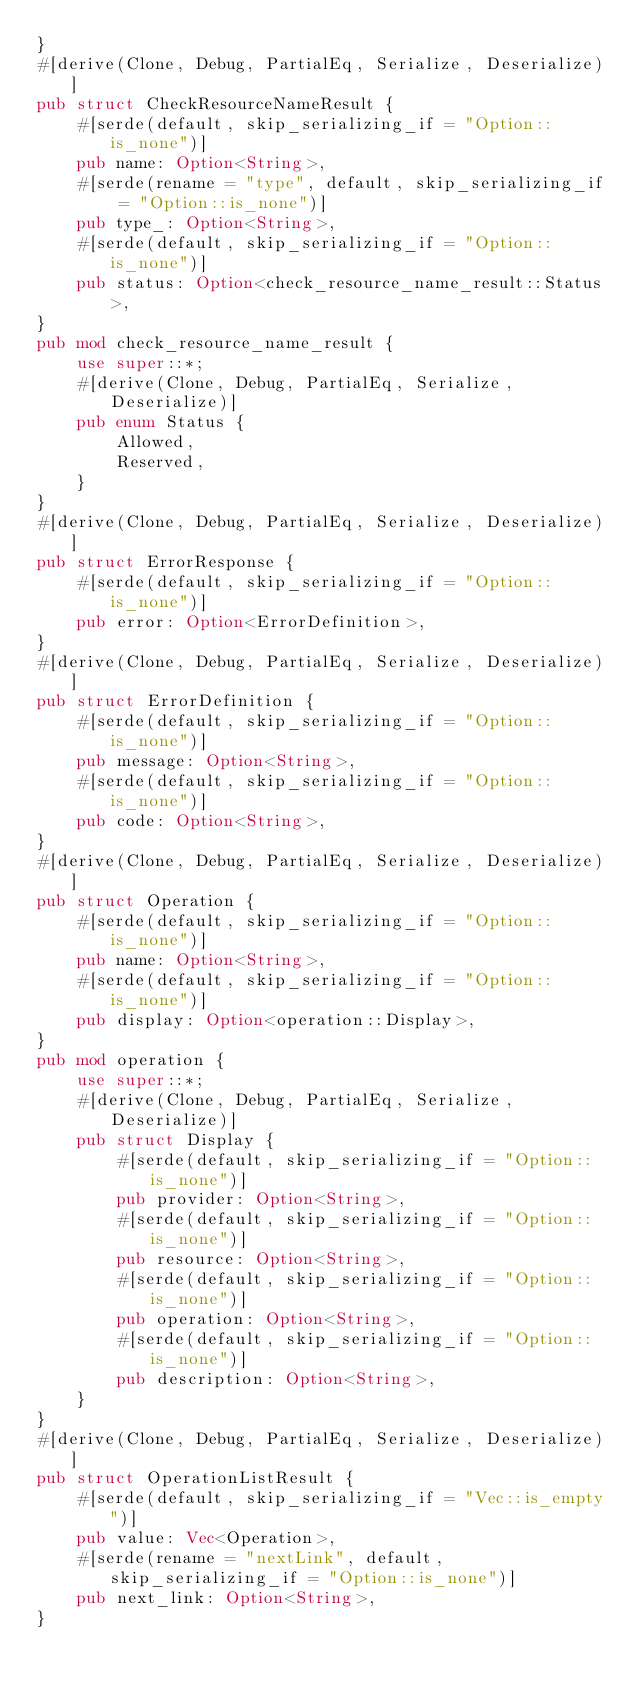Convert code to text. <code><loc_0><loc_0><loc_500><loc_500><_Rust_>}
#[derive(Clone, Debug, PartialEq, Serialize, Deserialize)]
pub struct CheckResourceNameResult {
    #[serde(default, skip_serializing_if = "Option::is_none")]
    pub name: Option<String>,
    #[serde(rename = "type", default, skip_serializing_if = "Option::is_none")]
    pub type_: Option<String>,
    #[serde(default, skip_serializing_if = "Option::is_none")]
    pub status: Option<check_resource_name_result::Status>,
}
pub mod check_resource_name_result {
    use super::*;
    #[derive(Clone, Debug, PartialEq, Serialize, Deserialize)]
    pub enum Status {
        Allowed,
        Reserved,
    }
}
#[derive(Clone, Debug, PartialEq, Serialize, Deserialize)]
pub struct ErrorResponse {
    #[serde(default, skip_serializing_if = "Option::is_none")]
    pub error: Option<ErrorDefinition>,
}
#[derive(Clone, Debug, PartialEq, Serialize, Deserialize)]
pub struct ErrorDefinition {
    #[serde(default, skip_serializing_if = "Option::is_none")]
    pub message: Option<String>,
    #[serde(default, skip_serializing_if = "Option::is_none")]
    pub code: Option<String>,
}
#[derive(Clone, Debug, PartialEq, Serialize, Deserialize)]
pub struct Operation {
    #[serde(default, skip_serializing_if = "Option::is_none")]
    pub name: Option<String>,
    #[serde(default, skip_serializing_if = "Option::is_none")]
    pub display: Option<operation::Display>,
}
pub mod operation {
    use super::*;
    #[derive(Clone, Debug, PartialEq, Serialize, Deserialize)]
    pub struct Display {
        #[serde(default, skip_serializing_if = "Option::is_none")]
        pub provider: Option<String>,
        #[serde(default, skip_serializing_if = "Option::is_none")]
        pub resource: Option<String>,
        #[serde(default, skip_serializing_if = "Option::is_none")]
        pub operation: Option<String>,
        #[serde(default, skip_serializing_if = "Option::is_none")]
        pub description: Option<String>,
    }
}
#[derive(Clone, Debug, PartialEq, Serialize, Deserialize)]
pub struct OperationListResult {
    #[serde(default, skip_serializing_if = "Vec::is_empty")]
    pub value: Vec<Operation>,
    #[serde(rename = "nextLink", default, skip_serializing_if = "Option::is_none")]
    pub next_link: Option<String>,
}
</code> 